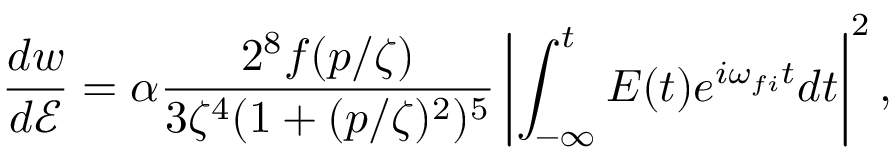Convert formula to latex. <formula><loc_0><loc_0><loc_500><loc_500>\frac { d w } { d \mathcal { E } } = \alpha \frac { 2 ^ { 8 } f ( p / \zeta ) } { 3 \zeta ^ { 4 } ( 1 + ( p / \zeta ) ^ { 2 } ) ^ { 5 } } \left | \int _ { - \infty } ^ { t } E ( t ) e ^ { i \omega _ { f i } t } d t \right | ^ { 2 } ,</formula> 